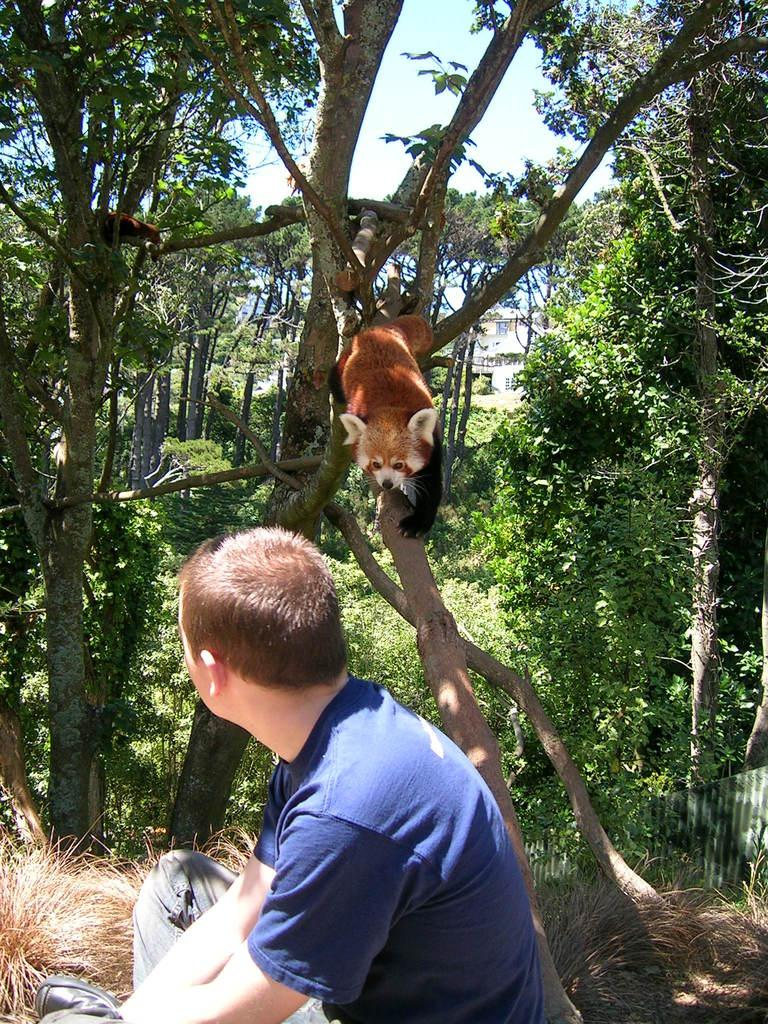What is the person in the image doing? The person is sitting on the grass. What type of vegetation can be seen in the image? There are trees and plants in the image. What is on the branch in the image? There is an animal on a branch. What can be seen in the background of the image? There is a building and the sky visible in the background of the image. What type of texture can be seen on the property in the image? A: There is no mention of a property in the image, and therefore no texture can be observed. 